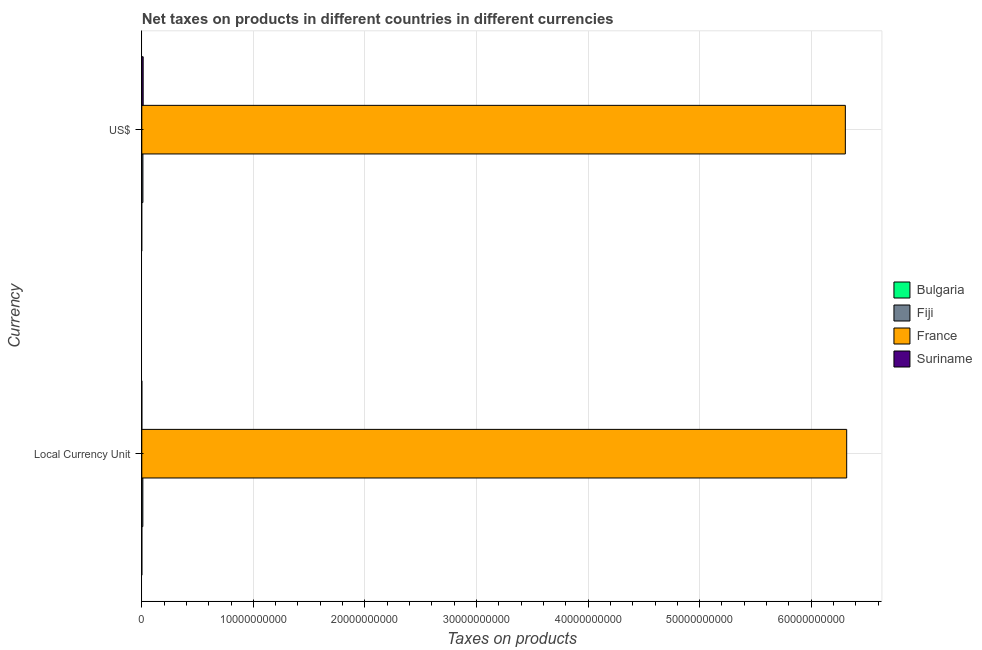How many groups of bars are there?
Your response must be concise. 2. Are the number of bars on each tick of the Y-axis equal?
Provide a succinct answer. Yes. How many bars are there on the 1st tick from the top?
Your answer should be very brief. 3. What is the label of the 2nd group of bars from the top?
Your answer should be compact. Local Currency Unit. What is the net taxes in us$ in Fiji?
Offer a very short reply. 9.96e+07. Across all countries, what is the maximum net taxes in us$?
Keep it short and to the point. 6.31e+1. Across all countries, what is the minimum net taxes in us$?
Ensure brevity in your answer.  0. In which country was the net taxes in constant 2005 us$ maximum?
Provide a succinct answer. France. What is the total net taxes in constant 2005 us$ in the graph?
Give a very brief answer. 6.33e+1. What is the difference between the net taxes in us$ in France and that in Fiji?
Provide a short and direct response. 6.30e+1. What is the difference between the net taxes in us$ in Bulgaria and the net taxes in constant 2005 us$ in Fiji?
Give a very brief answer. -9.28e+07. What is the average net taxes in constant 2005 us$ per country?
Offer a terse response. 1.58e+1. What is the difference between the net taxes in us$ and net taxes in constant 2005 us$ in France?
Offer a terse response. -1.20e+08. What is the ratio of the net taxes in us$ in Suriname to that in Fiji?
Offer a very short reply. 1.23. Is the net taxes in constant 2005 us$ in Suriname less than that in France?
Your response must be concise. Yes. How many bars are there?
Keep it short and to the point. 6. How many countries are there in the graph?
Your answer should be very brief. 4. How many legend labels are there?
Provide a succinct answer. 4. How are the legend labels stacked?
Ensure brevity in your answer.  Vertical. What is the title of the graph?
Your answer should be very brief. Net taxes on products in different countries in different currencies. What is the label or title of the X-axis?
Keep it short and to the point. Taxes on products. What is the label or title of the Y-axis?
Offer a very short reply. Currency. What is the Taxes on products of Fiji in Local Currency Unit?
Keep it short and to the point. 9.28e+07. What is the Taxes on products in France in Local Currency Unit?
Ensure brevity in your answer.  6.32e+1. What is the Taxes on products in Suriname in Local Currency Unit?
Provide a short and direct response. 2.45e+05. What is the Taxes on products in Fiji in US$?
Provide a succinct answer. 9.96e+07. What is the Taxes on products of France in US$?
Your answer should be compact. 6.31e+1. What is the Taxes on products of Suriname in US$?
Keep it short and to the point. 1.23e+08. Across all Currency, what is the maximum Taxes on products in Fiji?
Your response must be concise. 9.96e+07. Across all Currency, what is the maximum Taxes on products in France?
Your answer should be very brief. 6.32e+1. Across all Currency, what is the maximum Taxes on products of Suriname?
Give a very brief answer. 1.23e+08. Across all Currency, what is the minimum Taxes on products in Fiji?
Keep it short and to the point. 9.28e+07. Across all Currency, what is the minimum Taxes on products in France?
Provide a short and direct response. 6.31e+1. Across all Currency, what is the minimum Taxes on products in Suriname?
Ensure brevity in your answer.  2.45e+05. What is the total Taxes on products of Fiji in the graph?
Your answer should be very brief. 1.92e+08. What is the total Taxes on products in France in the graph?
Keep it short and to the point. 1.26e+11. What is the total Taxes on products of Suriname in the graph?
Your answer should be very brief. 1.23e+08. What is the difference between the Taxes on products in Fiji in Local Currency Unit and that in US$?
Make the answer very short. -6.73e+06. What is the difference between the Taxes on products of France in Local Currency Unit and that in US$?
Make the answer very short. 1.20e+08. What is the difference between the Taxes on products of Suriname in Local Currency Unit and that in US$?
Keep it short and to the point. -1.22e+08. What is the difference between the Taxes on products of Fiji in Local Currency Unit and the Taxes on products of France in US$?
Offer a terse response. -6.30e+1. What is the difference between the Taxes on products of Fiji in Local Currency Unit and the Taxes on products of Suriname in US$?
Keep it short and to the point. -2.97e+07. What is the difference between the Taxes on products of France in Local Currency Unit and the Taxes on products of Suriname in US$?
Provide a succinct answer. 6.31e+1. What is the average Taxes on products of Fiji per Currency?
Your answer should be very brief. 9.62e+07. What is the average Taxes on products of France per Currency?
Ensure brevity in your answer.  6.31e+1. What is the average Taxes on products in Suriname per Currency?
Give a very brief answer. 6.14e+07. What is the difference between the Taxes on products of Fiji and Taxes on products of France in Local Currency Unit?
Your answer should be compact. -6.31e+1. What is the difference between the Taxes on products in Fiji and Taxes on products in Suriname in Local Currency Unit?
Give a very brief answer. 9.26e+07. What is the difference between the Taxes on products of France and Taxes on products of Suriname in Local Currency Unit?
Provide a succinct answer. 6.32e+1. What is the difference between the Taxes on products in Fiji and Taxes on products in France in US$?
Provide a succinct answer. -6.30e+1. What is the difference between the Taxes on products in Fiji and Taxes on products in Suriname in US$?
Make the answer very short. -2.30e+07. What is the difference between the Taxes on products in France and Taxes on products in Suriname in US$?
Your response must be concise. 6.29e+1. What is the ratio of the Taxes on products of Fiji in Local Currency Unit to that in US$?
Provide a short and direct response. 0.93. What is the ratio of the Taxes on products in Suriname in Local Currency Unit to that in US$?
Provide a short and direct response. 0. What is the difference between the highest and the second highest Taxes on products of Fiji?
Offer a terse response. 6.73e+06. What is the difference between the highest and the second highest Taxes on products of France?
Offer a terse response. 1.20e+08. What is the difference between the highest and the second highest Taxes on products in Suriname?
Your answer should be very brief. 1.22e+08. What is the difference between the highest and the lowest Taxes on products of Fiji?
Your response must be concise. 6.73e+06. What is the difference between the highest and the lowest Taxes on products of France?
Offer a terse response. 1.20e+08. What is the difference between the highest and the lowest Taxes on products of Suriname?
Offer a very short reply. 1.22e+08. 